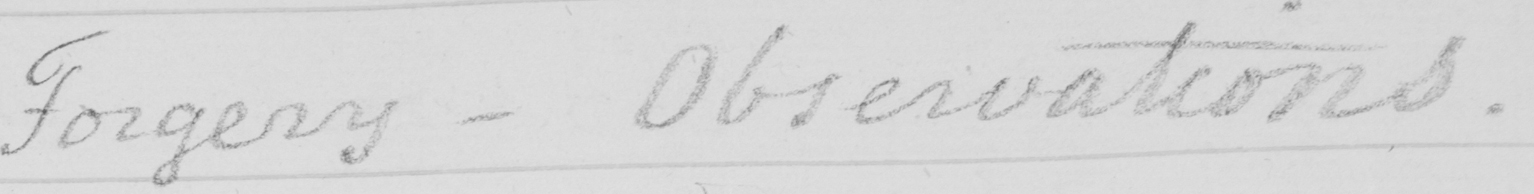What text is written in this handwritten line? Forgery - Observations . 